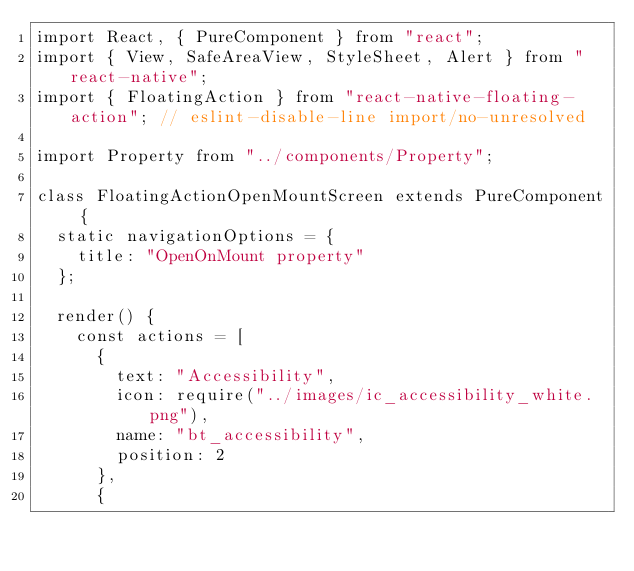Convert code to text. <code><loc_0><loc_0><loc_500><loc_500><_JavaScript_>import React, { PureComponent } from "react";
import { View, SafeAreaView, StyleSheet, Alert } from "react-native";
import { FloatingAction } from "react-native-floating-action"; // eslint-disable-line import/no-unresolved

import Property from "../components/Property";

class FloatingActionOpenMountScreen extends PureComponent {
  static navigationOptions = {
    title: "OpenOnMount property"
  };

  render() {
    const actions = [
      {
        text: "Accessibility",
        icon: require("../images/ic_accessibility_white.png"),
        name: "bt_accessibility",
        position: 2
      },
      {</code> 